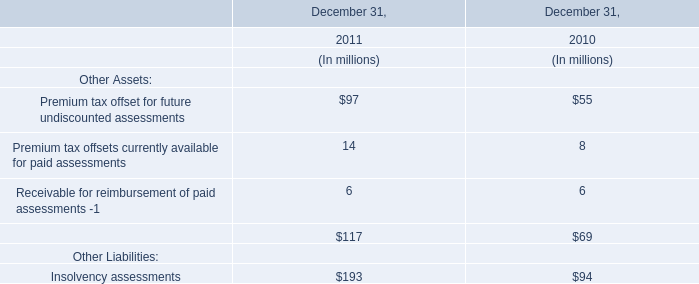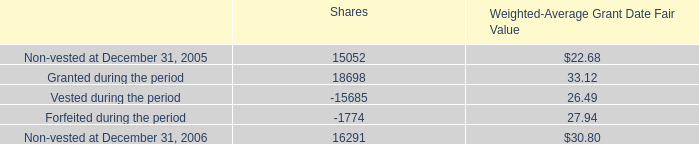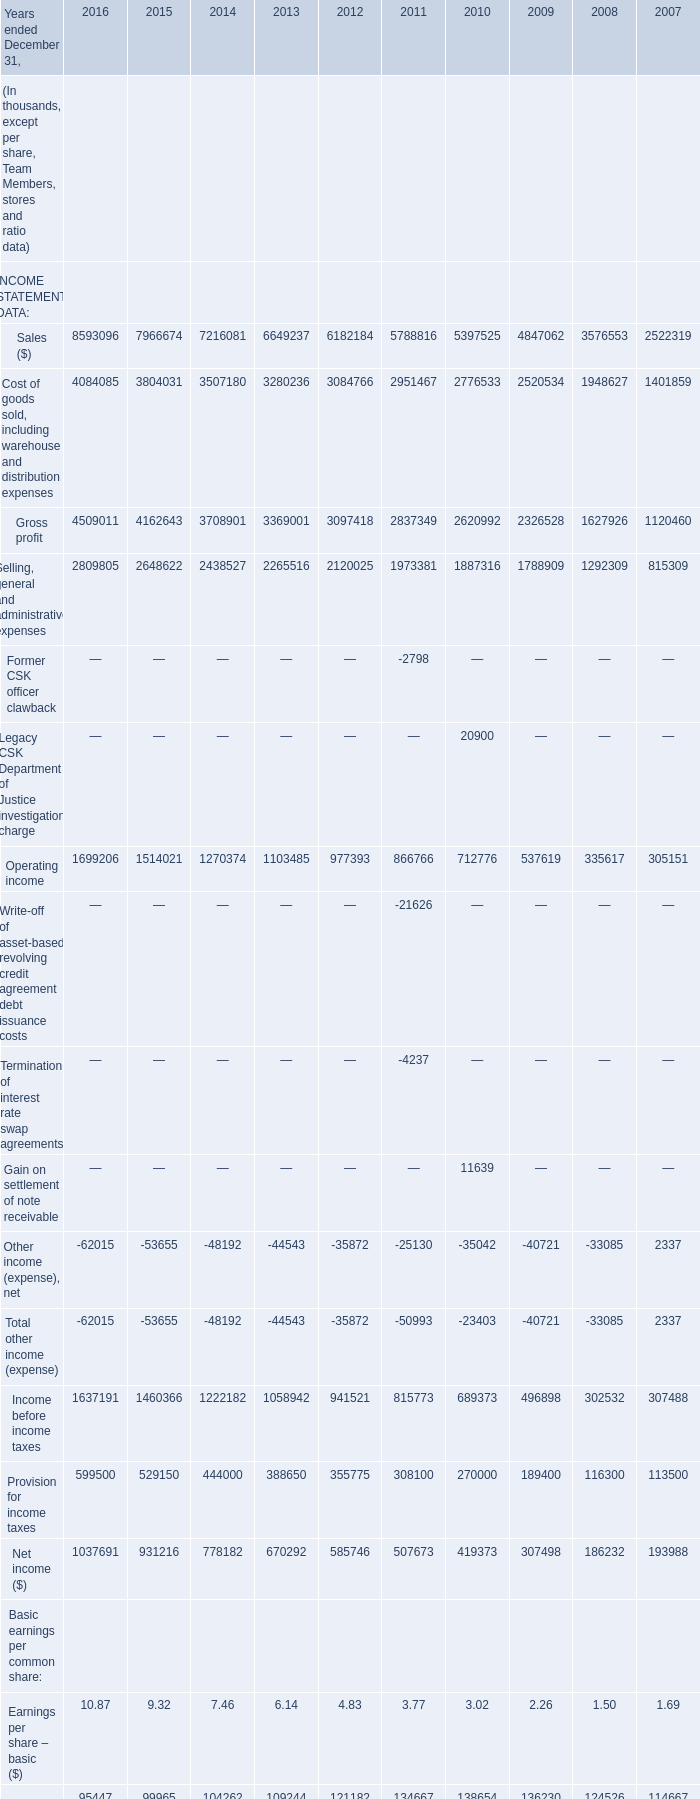what was the total value of the shares awarded under this plan in 2006 based on grant date value? 
Computations: (33.12 * 18698)
Answer: 619277.76. 